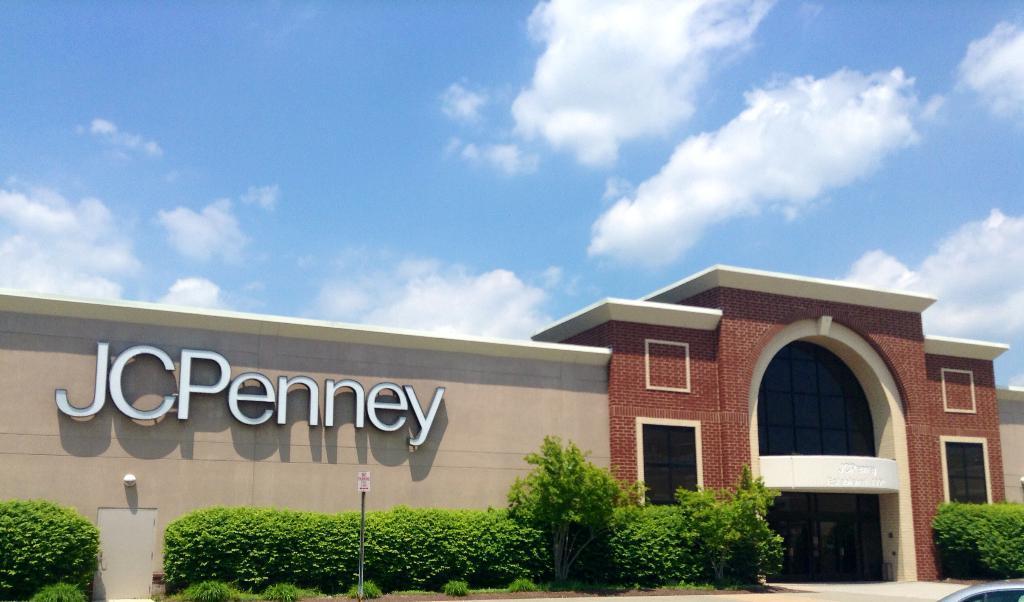Please provide a concise description of this image. In this picture we can see buildings. On the bottom we can see plants, trees and sign board. Here we can see door near to the plant. At the top we can see sky and clouds. 